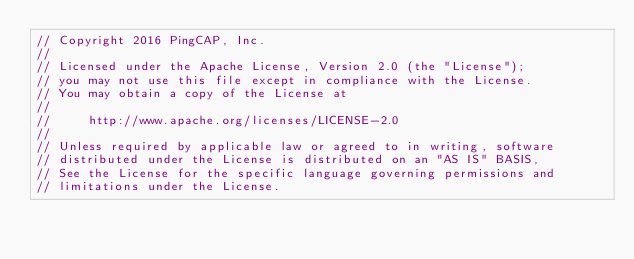<code> <loc_0><loc_0><loc_500><loc_500><_Go_>// Copyright 2016 PingCAP, Inc.
//
// Licensed under the Apache License, Version 2.0 (the "License");
// you may not use this file except in compliance with the License.
// You may obtain a copy of the License at
//
//     http://www.apache.org/licenses/LICENSE-2.0
//
// Unless required by applicable law or agreed to in writing, software
// distributed under the License is distributed on an "AS IS" BASIS,
// See the License for the specific language governing permissions and
// limitations under the License.
</code> 